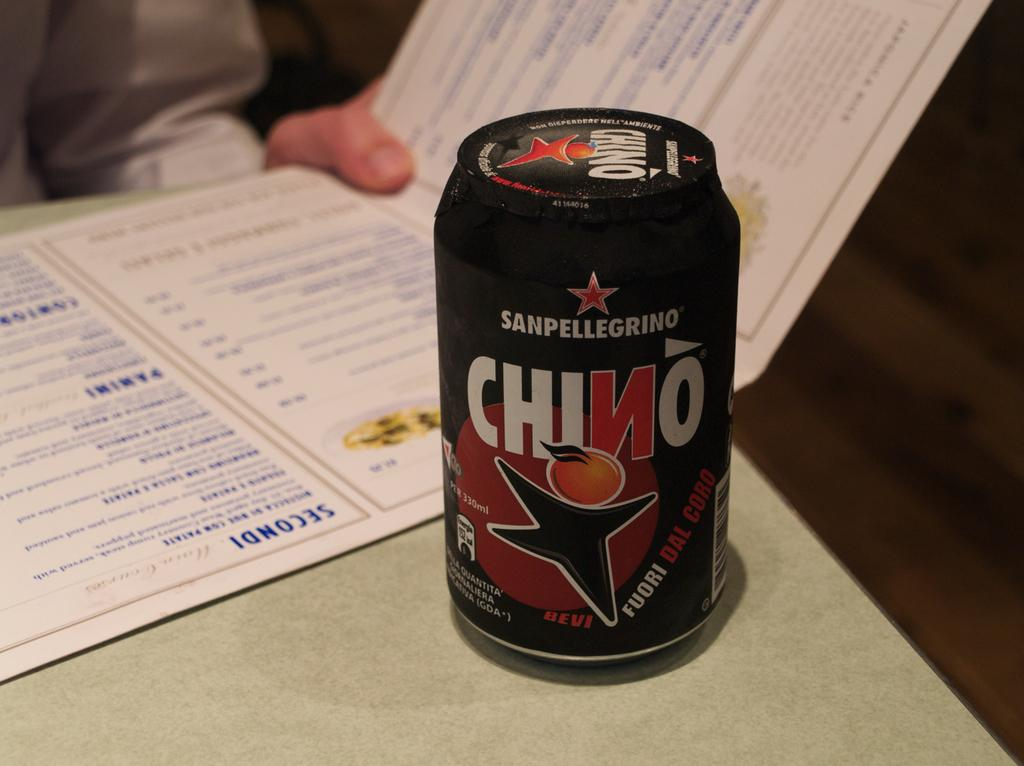<image>
Present a compact description of the photo's key features. A beverage called Chino is made by San Pellegrino and features a cartoon character with an orange for a head. 